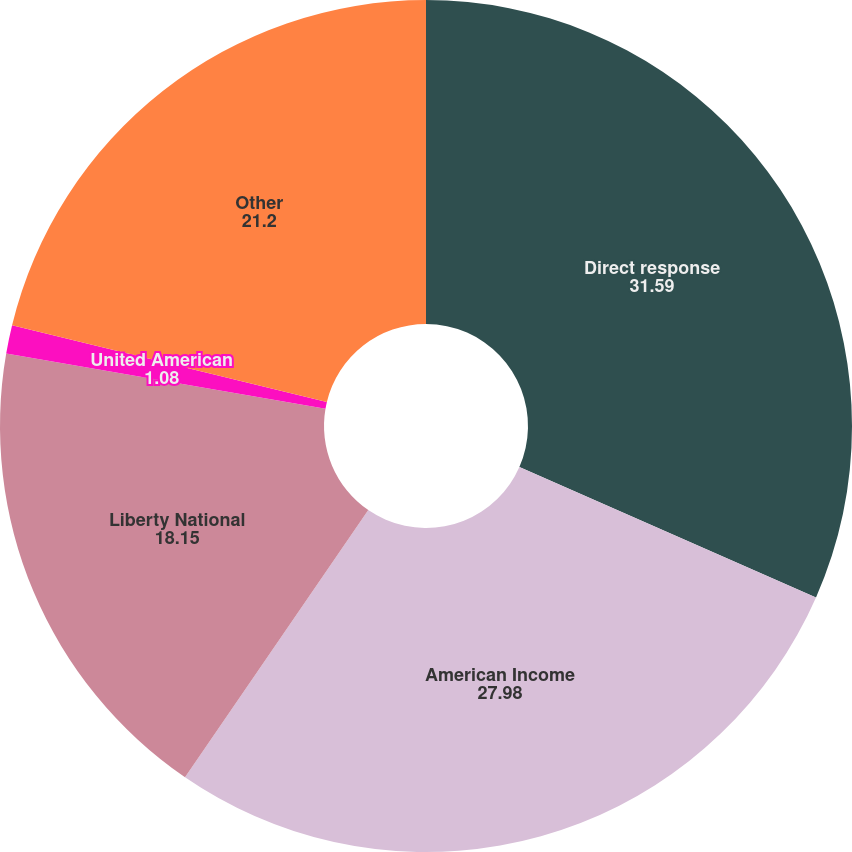Convert chart to OTSL. <chart><loc_0><loc_0><loc_500><loc_500><pie_chart><fcel>Direct response<fcel>American Income<fcel>Liberty National<fcel>United American<fcel>Other<nl><fcel>31.59%<fcel>27.98%<fcel>18.15%<fcel>1.08%<fcel>21.2%<nl></chart> 